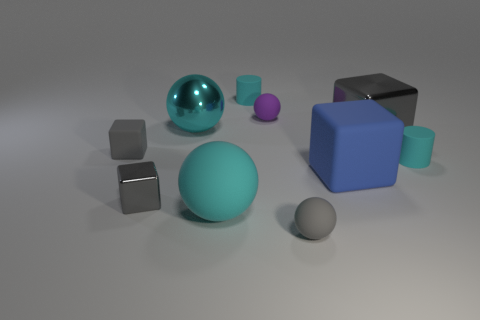Is there a small cyan cylinder to the left of the tiny matte cylinder that is on the left side of the gray rubber object that is in front of the blue cube?
Keep it short and to the point. No. There is another big cyan object that is the same shape as the large cyan rubber object; what material is it?
Make the answer very short. Metal. There is a large shiny cube in front of the purple ball; what is its color?
Offer a terse response. Gray. The blue cube is what size?
Ensure brevity in your answer.  Large. There is a purple object; does it have the same size as the cyan object that is in front of the tiny shiny object?
Ensure brevity in your answer.  No. The matte object that is to the right of the gray shiny cube that is right of the small sphere behind the big gray object is what color?
Make the answer very short. Cyan. Does the cyan ball that is in front of the big gray object have the same material as the big gray thing?
Ensure brevity in your answer.  No. How many other objects are there of the same material as the blue block?
Keep it short and to the point. 6. What material is the cyan thing that is the same size as the shiny ball?
Your answer should be very brief. Rubber. Is the shape of the big gray shiny thing to the right of the purple thing the same as the gray matte thing to the left of the small purple ball?
Offer a very short reply. Yes. 